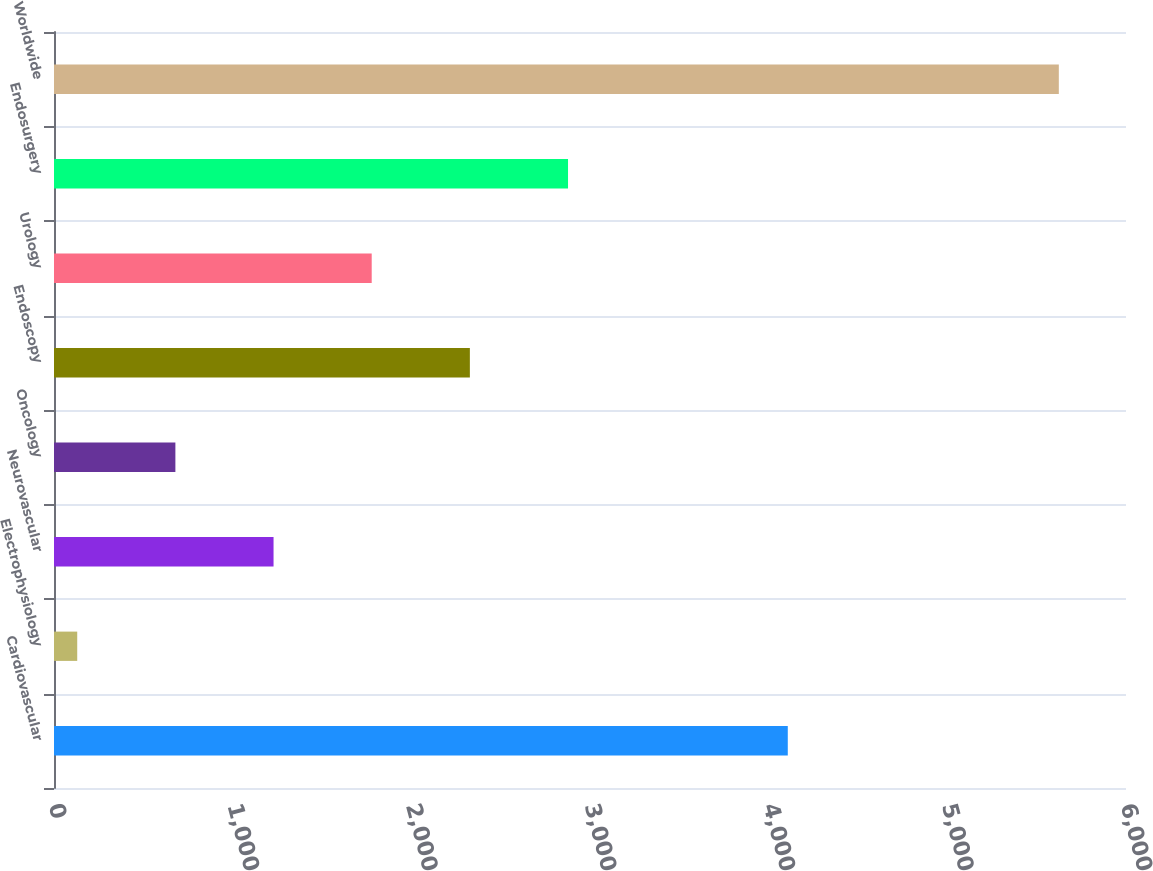<chart> <loc_0><loc_0><loc_500><loc_500><bar_chart><fcel>Cardiovascular<fcel>Electrophysiology<fcel>Neurovascular<fcel>Oncology<fcel>Endoscopy<fcel>Urology<fcel>Endosurgery<fcel>Worldwide<nl><fcel>4107<fcel>130<fcel>1228.8<fcel>679.4<fcel>2327.6<fcel>1778.2<fcel>2877<fcel>5624<nl></chart> 